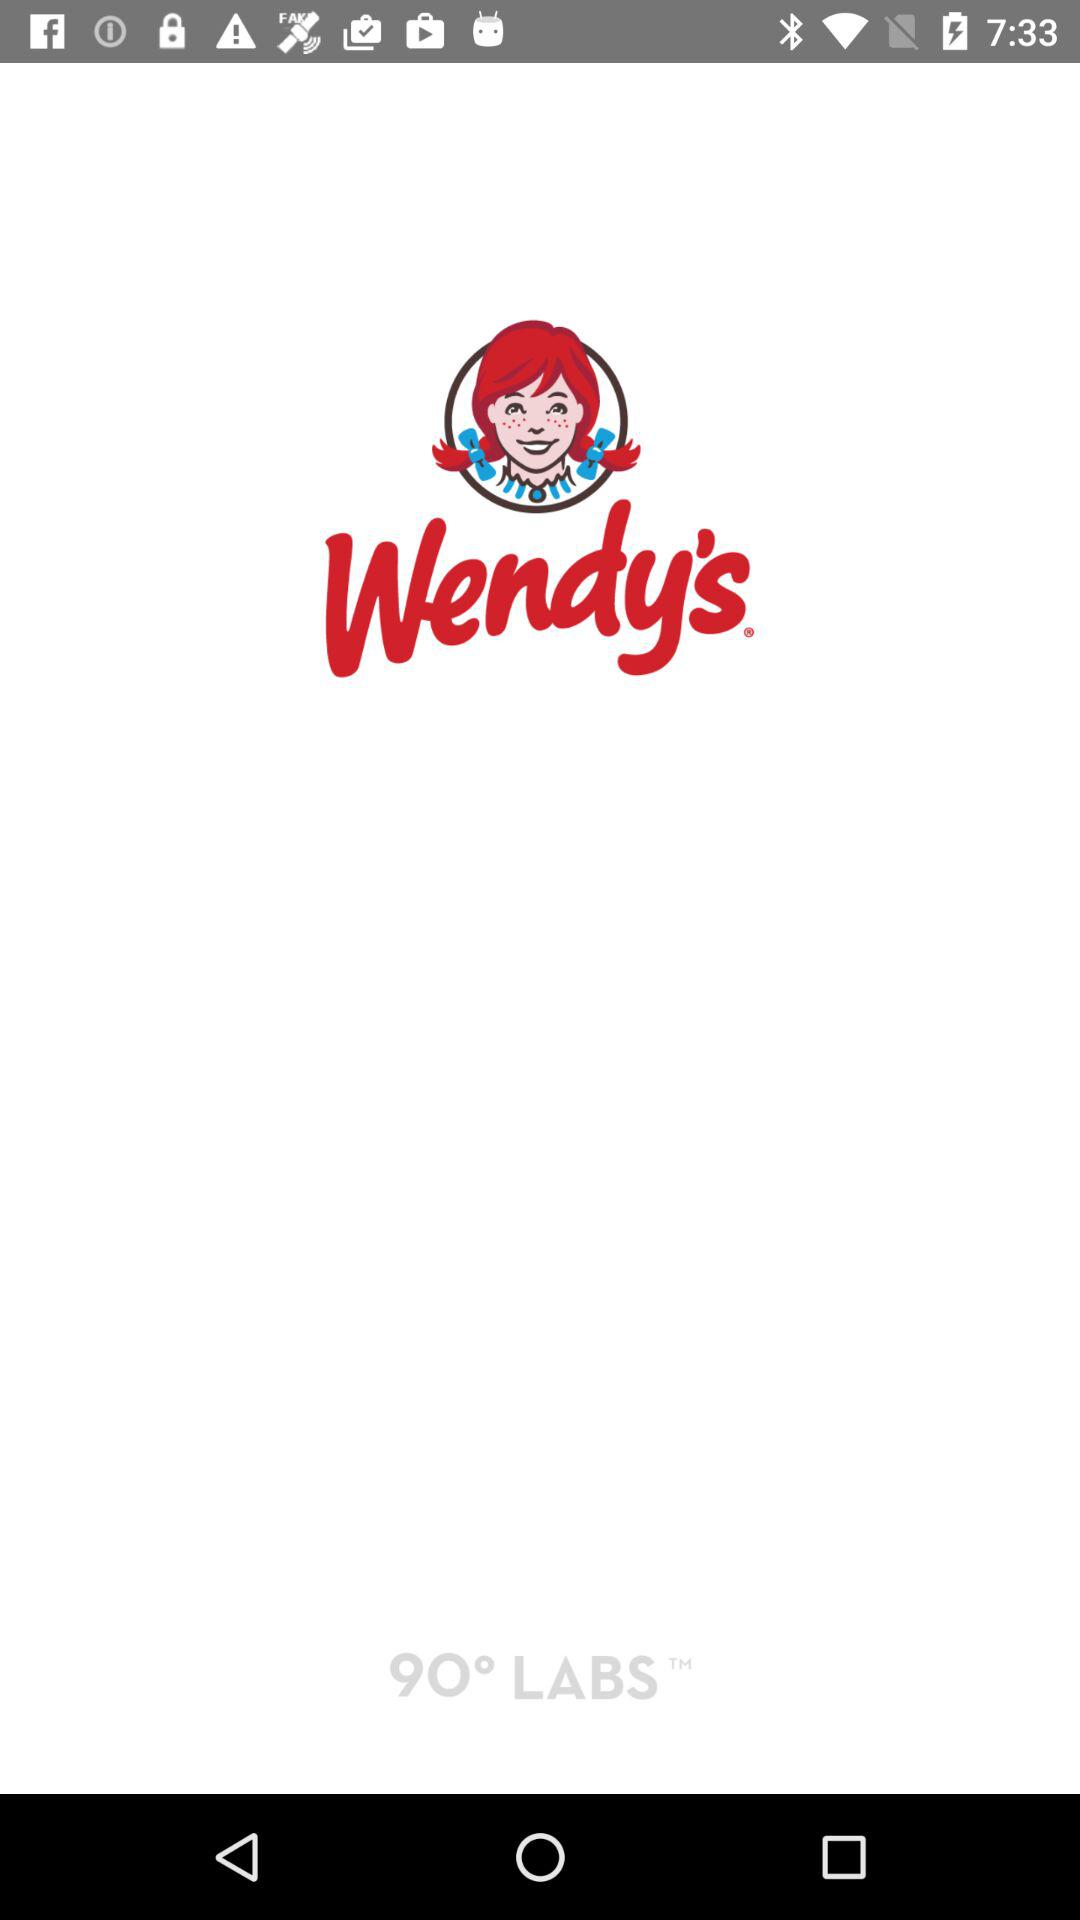What is the version of this application?
When the provided information is insufficient, respond with <no answer>. <no answer> 